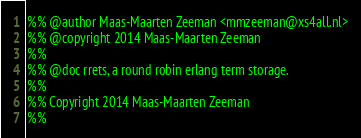Convert code to text. <code><loc_0><loc_0><loc_500><loc_500><_Erlang_>%% @author Maas-Maarten Zeeman <mmzeeman@xs4all.nl>
%% @copyright 2014 Maas-Maarten Zeeman
%%
%% @doc rrets, a round robin erlang term storage.
%%
%% Copyright 2014 Maas-Maarten Zeeman
%%</code> 